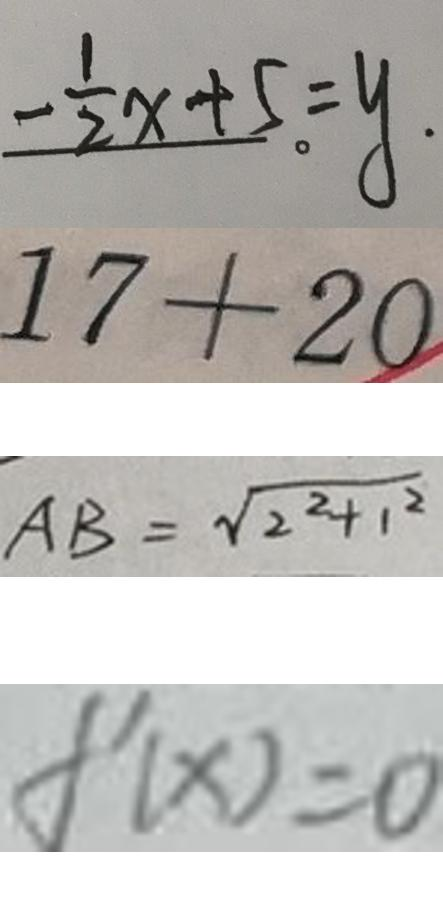<formula> <loc_0><loc_0><loc_500><loc_500>- \frac { 1 } { 2 } x + 5 = y . 
 1 7 + 2 0 
 A B = \sqrt { 2 ^ { 2 } + 1 ^ { 2 } } 
 f ^ { \prime } ( x ) = 0</formula> 